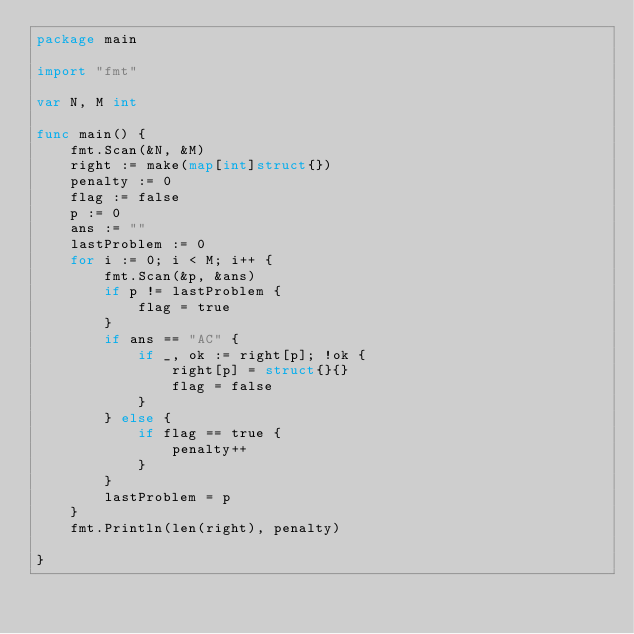Convert code to text. <code><loc_0><loc_0><loc_500><loc_500><_Go_>package main

import "fmt"

var N, M int

func main() {
	fmt.Scan(&N, &M)
	right := make(map[int]struct{})
	penalty := 0
	flag := false
	p := 0
	ans := ""
	lastProblem := 0
	for i := 0; i < M; i++ {
		fmt.Scan(&p, &ans)
		if p != lastProblem {
			flag = true
		}
		if ans == "AC" {
			if _, ok := right[p]; !ok {
				right[p] = struct{}{}
				flag = false
			}
		} else {
			if flag == true {
				penalty++
			}
		}
		lastProblem = p
	}
	fmt.Println(len(right), penalty)

}
</code> 